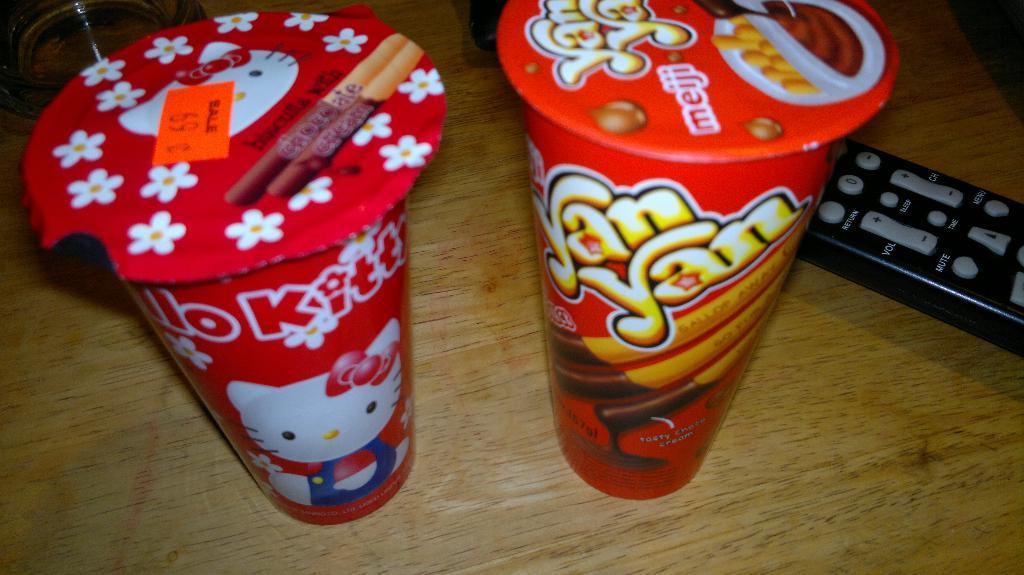Who is the famous mascot on the cup to the left?
Your answer should be compact. Hello kitty. 